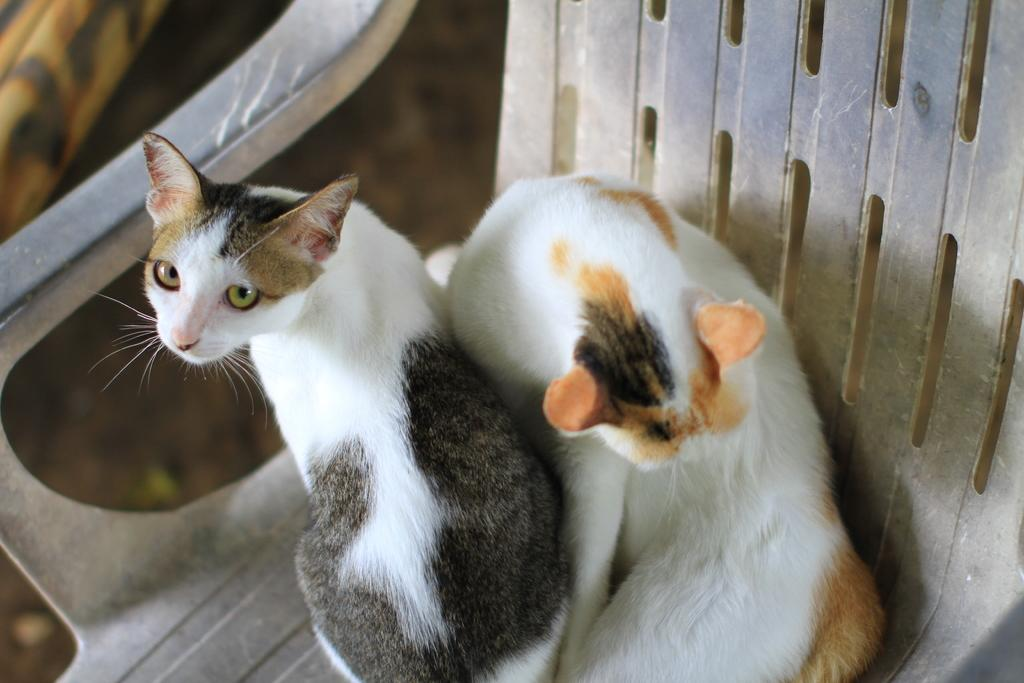How many cats are in the image? There are two cats in the image. What color combination do the cats have? The cats have a white and black color combination. Where are the cats sitting in the image? The cats are sitting on a gray color chair. How would you describe the background of the image? The background of the image is blurred. What type of brass instrument is the cat playing in the image? There is no brass instrument present in the image, and the cats are not playing any musical instruments. 